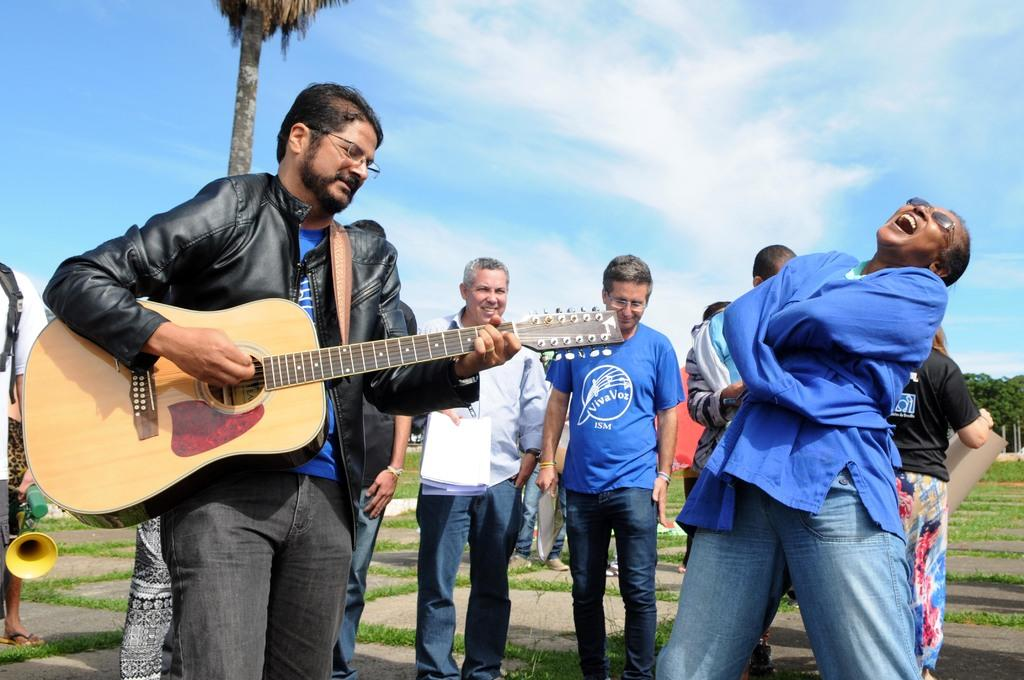How many people are in the image? There is a group of people in the image. What is one person doing in the image? One person is holding a guitar. What is another person doing in the image? Another person is laughing. What can be seen in the background of the image? There is a tree and the sky visible in the background of the image. How many toads are sitting on the guitar in the image? There are no toads present in the image, and the guitar is not being used as a seat for any animals. 